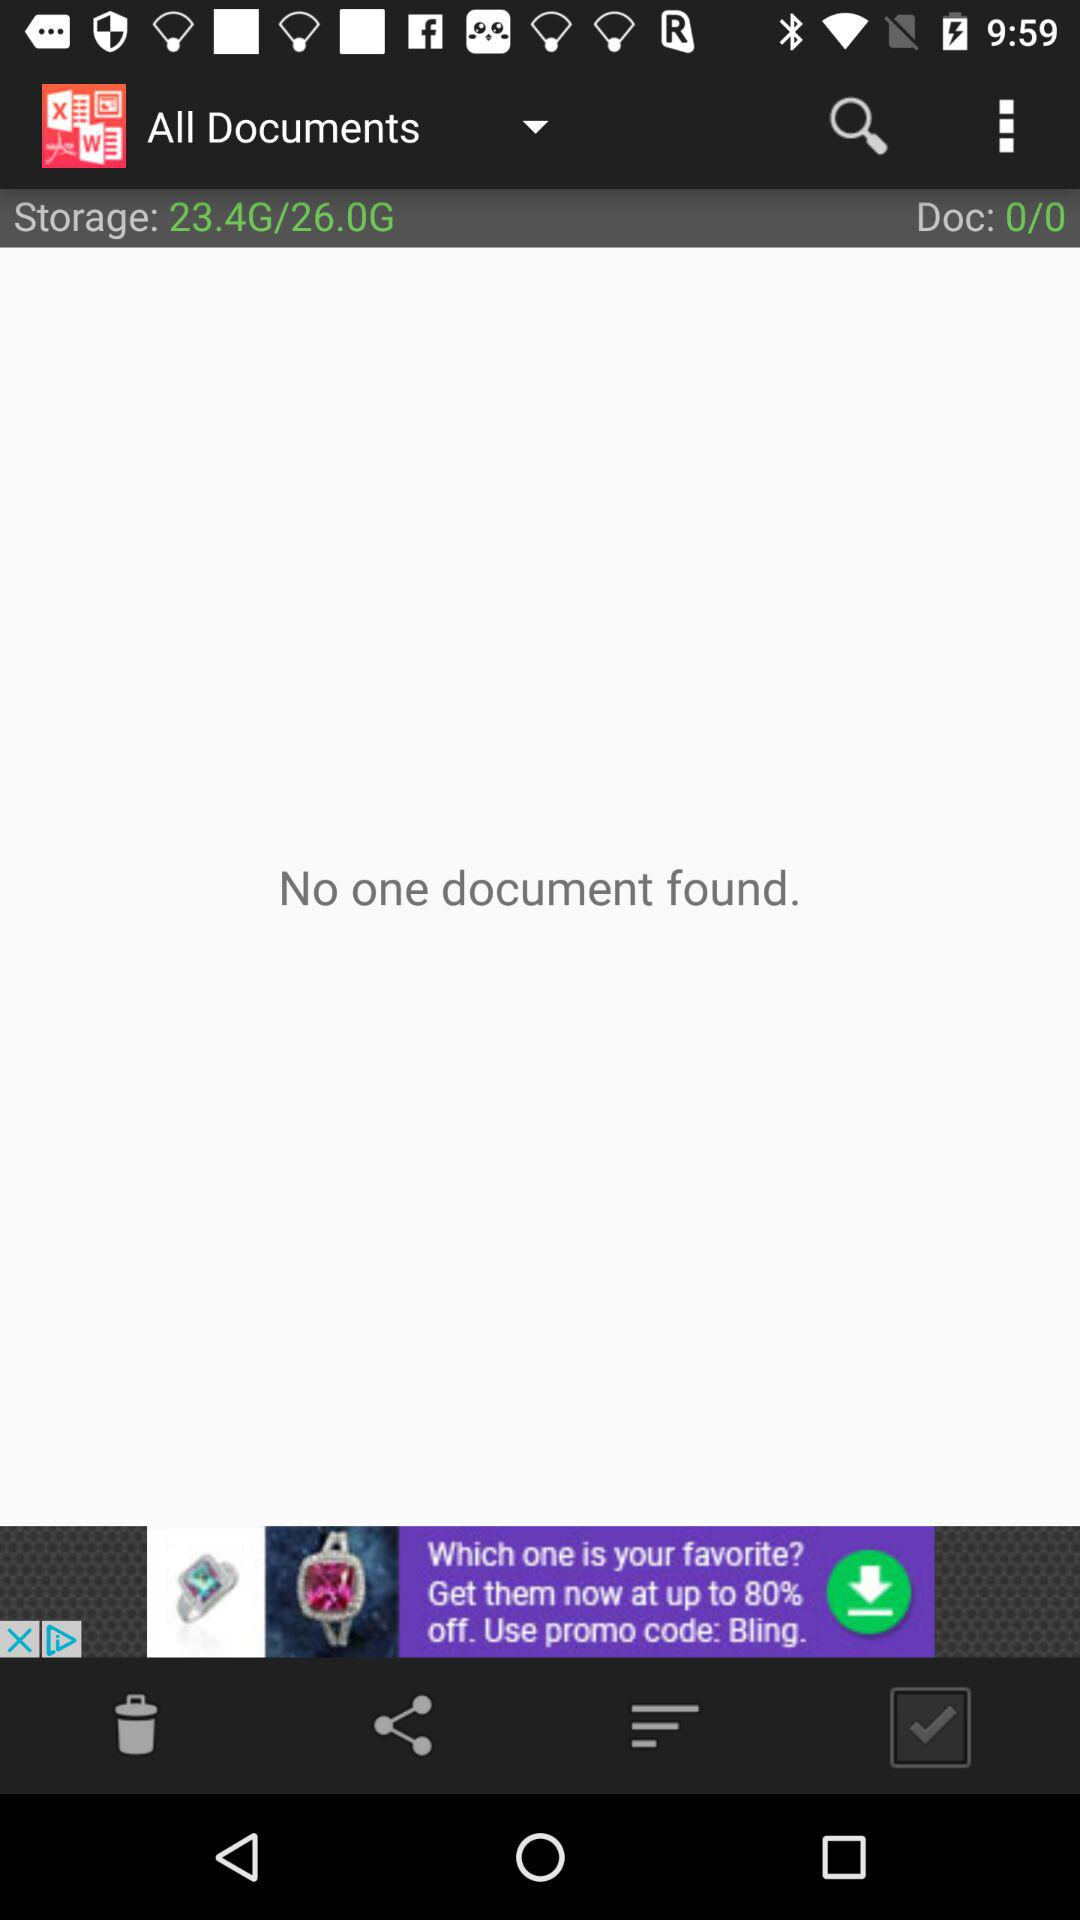What is the total storage capacity available? The total storage capacity available is 26.0 GB. 